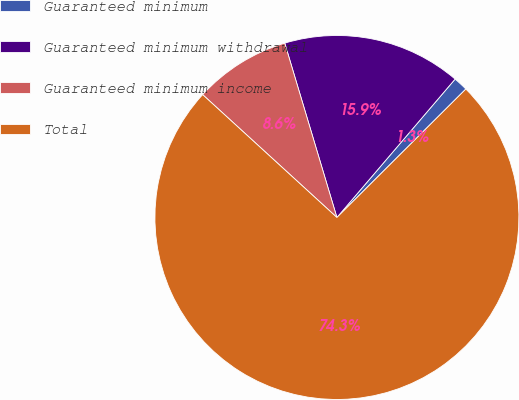Convert chart to OTSL. <chart><loc_0><loc_0><loc_500><loc_500><pie_chart><fcel>Guaranteed minimum<fcel>Guaranteed minimum withdrawal<fcel>Guaranteed minimum income<fcel>Total<nl><fcel>1.28%<fcel>15.88%<fcel>8.58%<fcel>74.27%<nl></chart> 